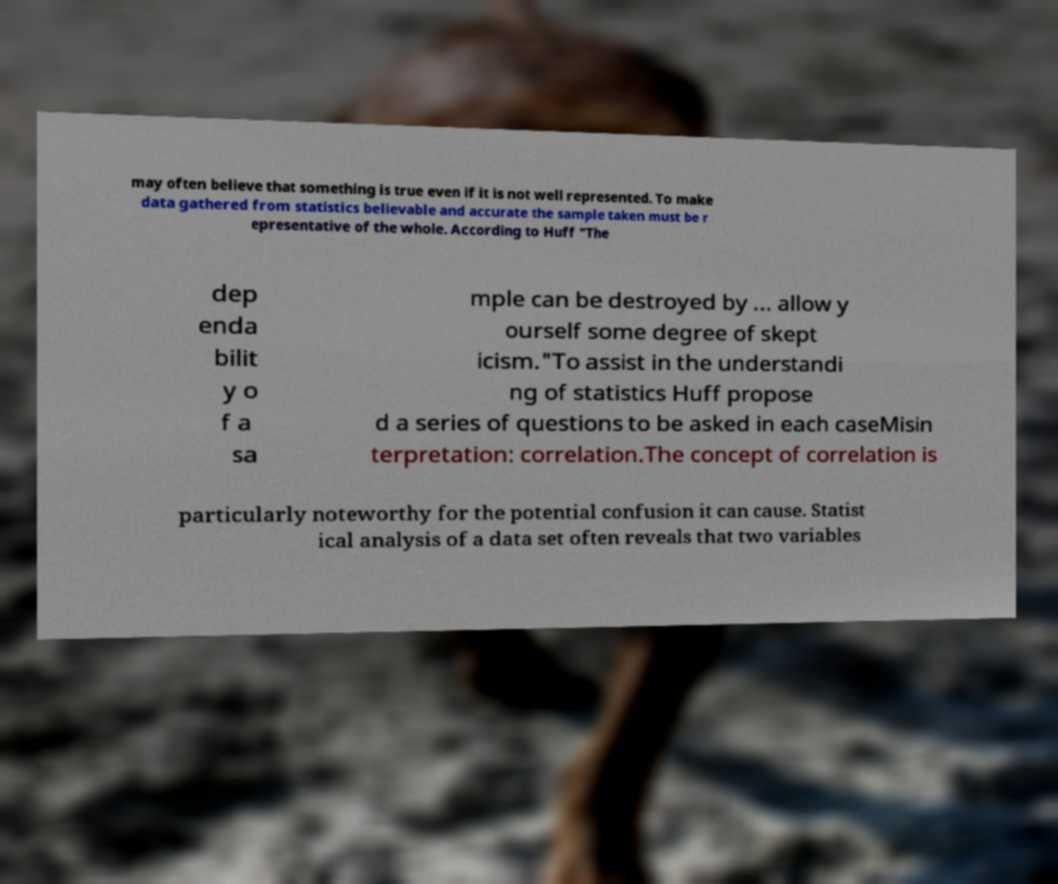I need the written content from this picture converted into text. Can you do that? may often believe that something is true even if it is not well represented. To make data gathered from statistics believable and accurate the sample taken must be r epresentative of the whole. According to Huff "The dep enda bilit y o f a sa mple can be destroyed by ... allow y ourself some degree of skept icism."To assist in the understandi ng of statistics Huff propose d a series of questions to be asked in each caseMisin terpretation: correlation.The concept of correlation is particularly noteworthy for the potential confusion it can cause. Statist ical analysis of a data set often reveals that two variables 